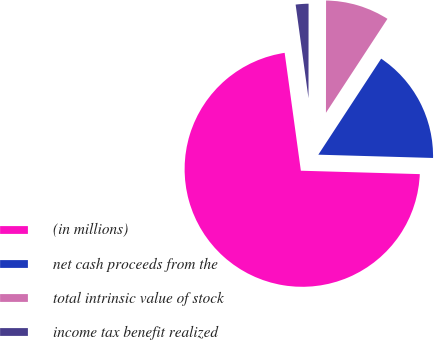<chart> <loc_0><loc_0><loc_500><loc_500><pie_chart><fcel>(in millions)<fcel>net cash proceeds from the<fcel>total intrinsic value of stock<fcel>income tax benefit realized<nl><fcel>72.37%<fcel>16.23%<fcel>9.21%<fcel>2.19%<nl></chart> 